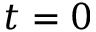Convert formula to latex. <formula><loc_0><loc_0><loc_500><loc_500>t = 0</formula> 